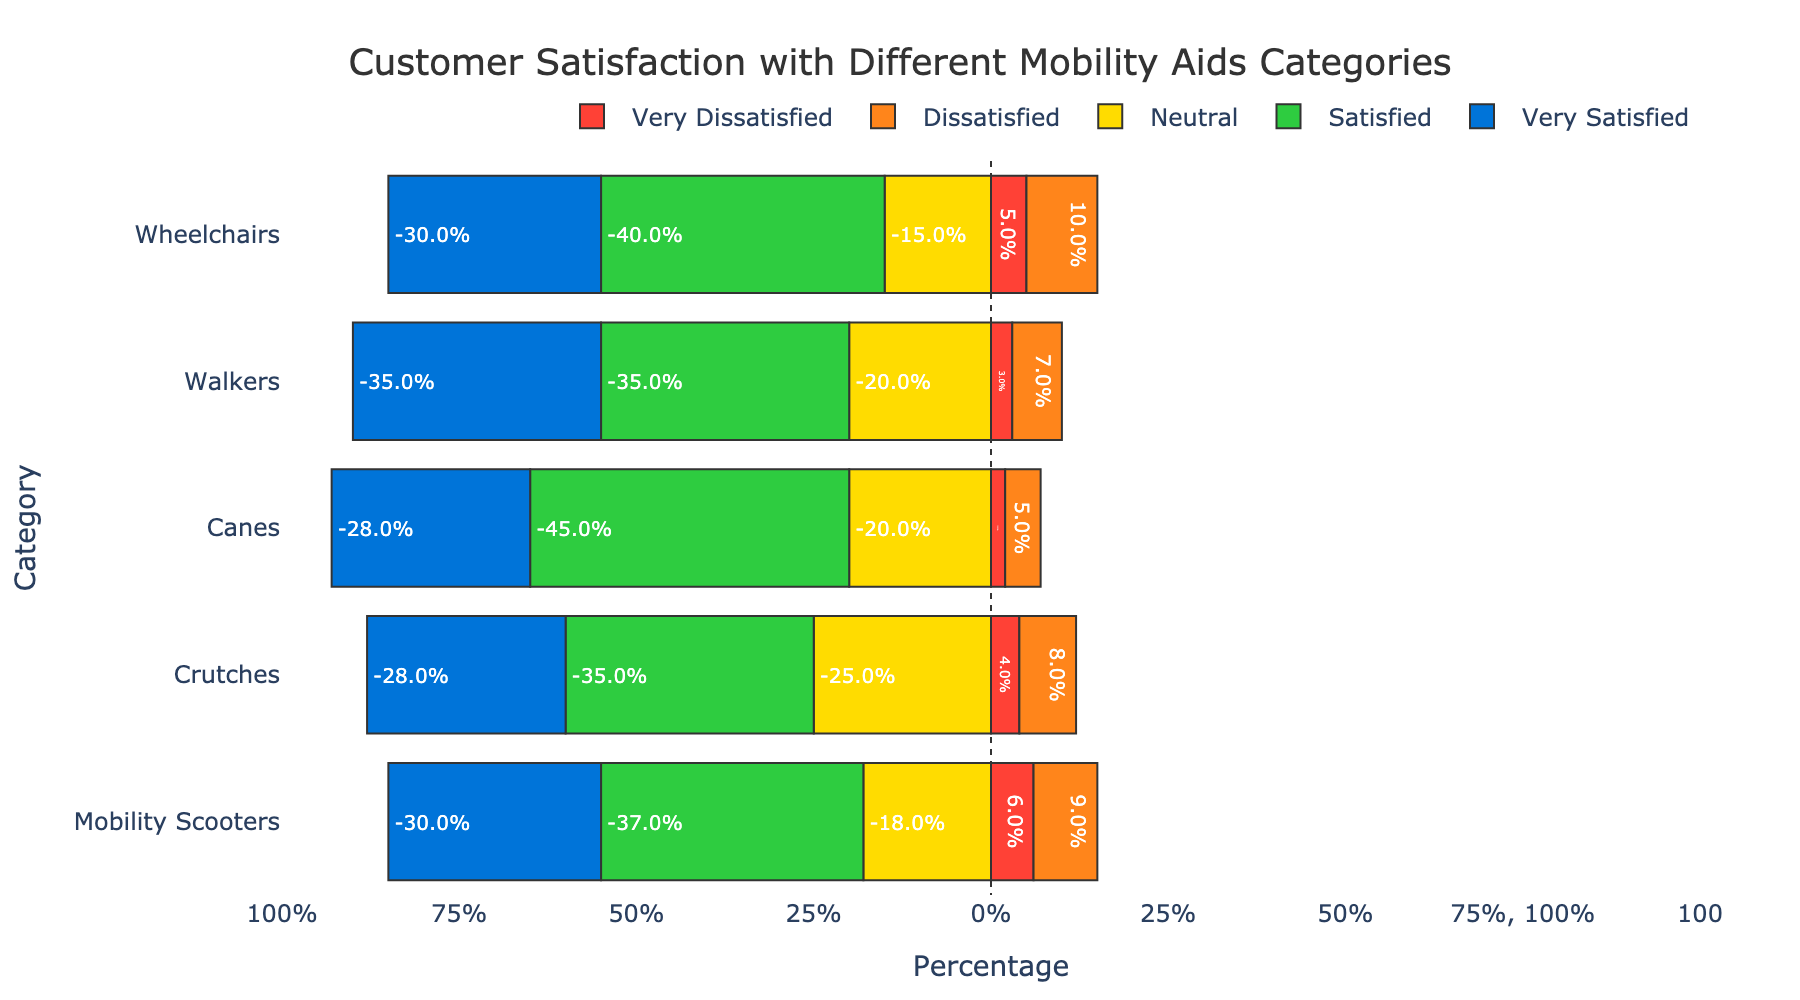How many customers are satisfied or very satisfied with canes? Sum the counts of satisfied and very satisfied categories for canes: 45 (satisfied) + 28 (very satisfied) = 73
Answer: 73 Which mobility aid category has the highest percentage of neutral responses? Compare the neutral response percentages for all categories: Wheelchairs (15%), Walkers (20%), Canes (20%), Crutches (25%), Mobility Scooters (18%). Crutches have the highest percentage of neutral responses.
Answer: Crutches What percentage of customers are dissatisfied with wheelchairs? Add the percentages of dissatisfied and very dissatisfied for wheelchairs: 5% (very dissatisfied) + 10% (dissatisfied) = 15%
Answer: 15% Between wheelchairs and mobility scooters, which has a higher percentage of very satisfied customers? Compare the very satisfied percentages: Wheelchairs (30%), Mobility Scooters (30%). Both have equal percentages.
Answer: Both are equal What is the total percentage of neutral or higher satisfaction for walkers? Sum satisfied and very satisfied percentages for walkers: 35% (satisfied) + 35% (very satisfied) = 70%. Add neutral percentage: 70% + 20% (neutral) = 90%
Answer: 90% Which category has the lowest percentage of dissatisfied responses? Compare very dissatisfied and dissatisfied percentages for each category: Wheelchairs (5%+10%), Walkers (3%+7%), Canes (2%+5%), Crutches (4%+8%), Mobility Scooters (6%+9%). Canes have the lowest with 2%+5%=7%.
Answer: Canes For crutches, what is the combined percentage of satisfied and very satisfied customers? Add satisfied and very satisfied percentages for crutches: 35% (satisfied) + 28% (very satisfied) = 63%
Answer: 63% Which mobility aid category has the most balanced distribution of customer satisfaction? Look for the category with the most even spread across all response categories. Walkers appear to have a relatively balanced distribution with percentages ranging more closely (3%, 7%, 20%, 35%, 35%) compared to others.
Answer: Walkers Are there more customers very satisfied with canes or satisfied with wheelchairs? Compare the counts: Canes (very satisfied: 28), Wheelchairs (satisfied: 40). Wheelchairs have more satisfied customers.
Answer: Wheelchairs 